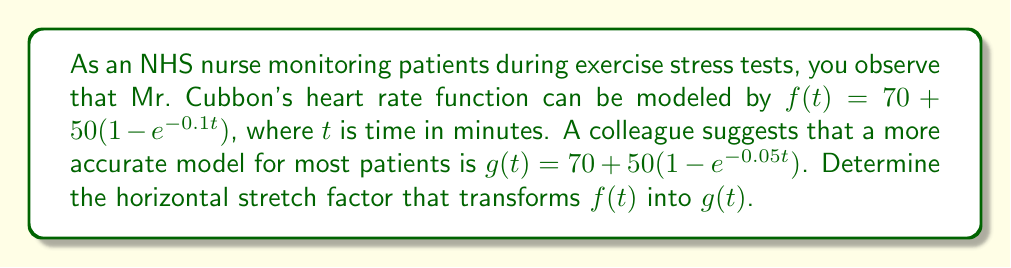Can you solve this math problem? To find the horizontal stretch factor, we need to compare the equations of $f(t)$ and $g(t)$.

1) The general form of a horizontal stretch is:
   If $y = f(t)$, then $y = f(\frac{t}{k})$ represents a horizontal stretch by a factor of $k$.

2) Looking at the exponents in both functions:
   $f(t)$ has $e^{-0.1t}$
   $g(t)$ has $e^{-0.05t}$

3) We can rewrite $g(t)$ in terms of $f(t)$:
   $g(t) = 70 + 50(1 - e^{-0.05t})$
         $= 70 + 50(1 - e^{-0.1(\frac{t}{2})})$

4) This shows that $g(t) = f(\frac{t}{2})$

5) Comparing with the general form $f(\frac{t}{k})$, we see that $k = 2$

Therefore, the horizontal stretch factor is 2, meaning the graph of $g(t)$ is stretched horizontally by a factor of 2 compared to $f(t)$.
Answer: The horizontal stretch factor is 2. 